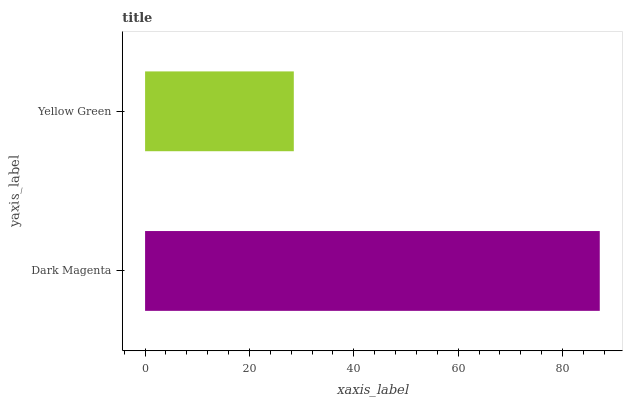Is Yellow Green the minimum?
Answer yes or no. Yes. Is Dark Magenta the maximum?
Answer yes or no. Yes. Is Yellow Green the maximum?
Answer yes or no. No. Is Dark Magenta greater than Yellow Green?
Answer yes or no. Yes. Is Yellow Green less than Dark Magenta?
Answer yes or no. Yes. Is Yellow Green greater than Dark Magenta?
Answer yes or no. No. Is Dark Magenta less than Yellow Green?
Answer yes or no. No. Is Dark Magenta the high median?
Answer yes or no. Yes. Is Yellow Green the low median?
Answer yes or no. Yes. Is Yellow Green the high median?
Answer yes or no. No. Is Dark Magenta the low median?
Answer yes or no. No. 